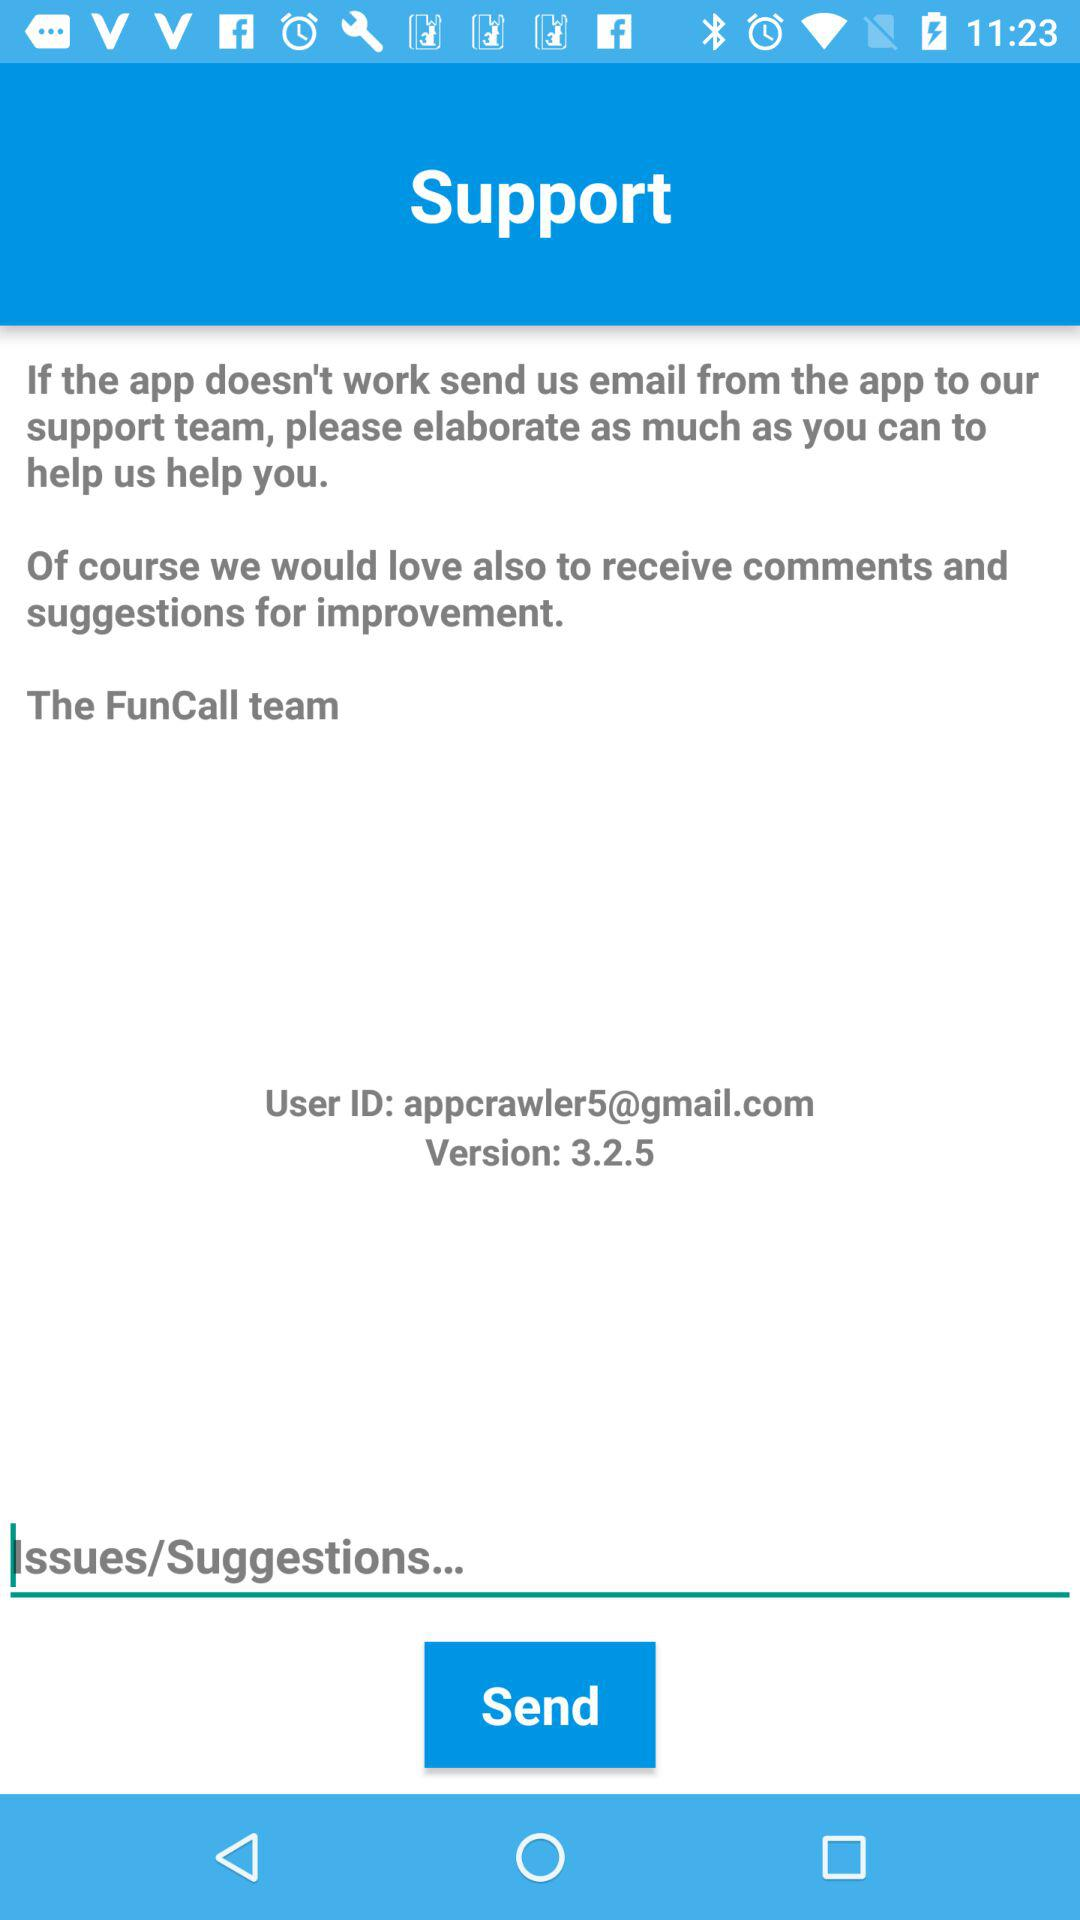What is the user ID? The user ID is appcrawler5@gmail.com. 